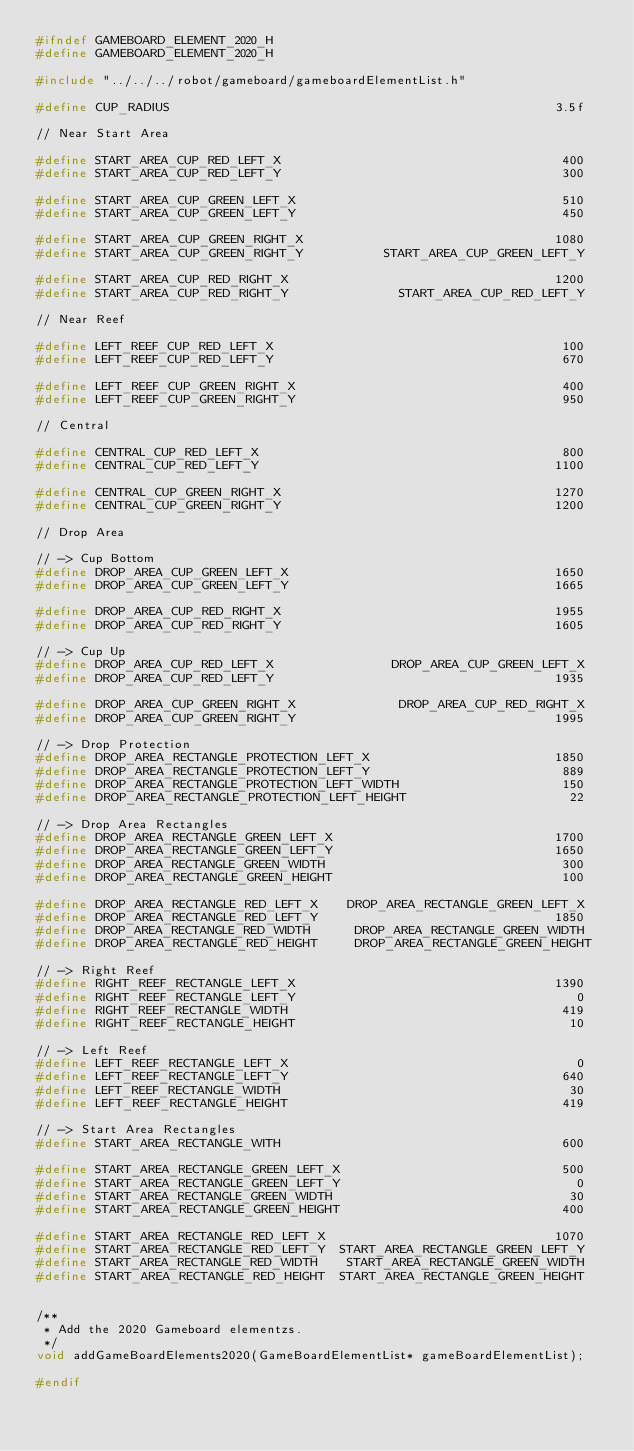<code> <loc_0><loc_0><loc_500><loc_500><_C_>#ifndef GAMEBOARD_ELEMENT_2020_H
#define GAMEBOARD_ELEMENT_2020_H

#include "../../../robot/gameboard/gameboardElementList.h"

#define CUP_RADIUS                                                    3.5f

// Near Start Area

#define START_AREA_CUP_RED_LEFT_X                                      400
#define START_AREA_CUP_RED_LEFT_Y                                      300

#define START_AREA_CUP_GREEN_LEFT_X                                    510
#define START_AREA_CUP_GREEN_LEFT_Y                                    450

#define START_AREA_CUP_GREEN_RIGHT_X                                  1080
#define START_AREA_CUP_GREEN_RIGHT_Y           START_AREA_CUP_GREEN_LEFT_Y

#define START_AREA_CUP_RED_RIGHT_X                                    1200
#define START_AREA_CUP_RED_RIGHT_Y               START_AREA_CUP_RED_LEFT_Y

// Near Reef

#define LEFT_REEF_CUP_RED_LEFT_X                                       100
#define LEFT_REEF_CUP_RED_LEFT_Y                                       670

#define LEFT_REEF_CUP_GREEN_RIGHT_X                                    400
#define LEFT_REEF_CUP_GREEN_RIGHT_Y                                    950

// Central

#define CENTRAL_CUP_RED_LEFT_X                                         800
#define CENTRAL_CUP_RED_LEFT_Y                                        1100

#define CENTRAL_CUP_GREEN_RIGHT_X                                     1270
#define CENTRAL_CUP_GREEN_RIGHT_Y                                     1200

// Drop Area

// -> Cup Bottom
#define DROP_AREA_CUP_GREEN_LEFT_X                                    1650
#define DROP_AREA_CUP_GREEN_LEFT_Y                                    1665

#define DROP_AREA_CUP_RED_RIGHT_X                                     1955
#define DROP_AREA_CUP_RED_RIGHT_Y                                     1605

// -> Cup Up
#define DROP_AREA_CUP_RED_LEFT_X                DROP_AREA_CUP_GREEN_LEFT_X
#define DROP_AREA_CUP_RED_LEFT_Y                                      1935

#define DROP_AREA_CUP_GREEN_RIGHT_X              DROP_AREA_CUP_RED_RIGHT_X
#define DROP_AREA_CUP_GREEN_RIGHT_Y                                   1995

// -> Drop Protection
#define DROP_AREA_RECTANGLE_PROTECTION_LEFT_X                         1850
#define DROP_AREA_RECTANGLE_PROTECTION_LEFT_Y                          889
#define DROP_AREA_RECTANGLE_PROTECTION_LEFT_WIDTH                      150
#define DROP_AREA_RECTANGLE_PROTECTION_LEFT_HEIGHT                      22

// -> Drop Area Rectangles
#define DROP_AREA_RECTANGLE_GREEN_LEFT_X                              1700
#define DROP_AREA_RECTANGLE_GREEN_LEFT_Y                              1650
#define DROP_AREA_RECTANGLE_GREEN_WIDTH                                300
#define DROP_AREA_RECTANGLE_GREEN_HEIGHT                               100

#define DROP_AREA_RECTANGLE_RED_LEFT_X    DROP_AREA_RECTANGLE_GREEN_LEFT_X
#define DROP_AREA_RECTANGLE_RED_LEFT_Y                                1850
#define DROP_AREA_RECTANGLE_RED_WIDTH      DROP_AREA_RECTANGLE_GREEN_WIDTH
#define DROP_AREA_RECTANGLE_RED_HEIGHT     DROP_AREA_RECTANGLE_GREEN_HEIGHT

// -> Right Reef
#define RIGHT_REEF_RECTANGLE_LEFT_X                                   1390
#define RIGHT_REEF_RECTANGLE_LEFT_Y                                      0
#define RIGHT_REEF_RECTANGLE_WIDTH                                     419
#define RIGHT_REEF_RECTANGLE_HEIGHT                                     10

// -> Left Reef
#define LEFT_REEF_RECTANGLE_LEFT_X                                       0
#define LEFT_REEF_RECTANGLE_LEFT_Y                                     640
#define LEFT_REEF_RECTANGLE_WIDTH                                       30
#define LEFT_REEF_RECTANGLE_HEIGHT                                     419

// -> Start Area Rectangles
#define START_AREA_RECTANGLE_WITH                                      600

#define START_AREA_RECTANGLE_GREEN_LEFT_X                              500
#define START_AREA_RECTANGLE_GREEN_LEFT_Y                                0
#define START_AREA_RECTANGLE_GREEN_WIDTH                                30
#define START_AREA_RECTANGLE_GREEN_HEIGHT                              400

#define START_AREA_RECTANGLE_RED_LEFT_X                               1070
#define START_AREA_RECTANGLE_RED_LEFT_Y  START_AREA_RECTANGLE_GREEN_LEFT_Y
#define START_AREA_RECTANGLE_RED_WIDTH    START_AREA_RECTANGLE_GREEN_WIDTH
#define START_AREA_RECTANGLE_RED_HEIGHT  START_AREA_RECTANGLE_GREEN_HEIGHT


/**
 * Add the 2020 Gameboard elementzs.
 */
void addGameBoardElements2020(GameBoardElementList* gameBoardElementList);

#endif
</code> 